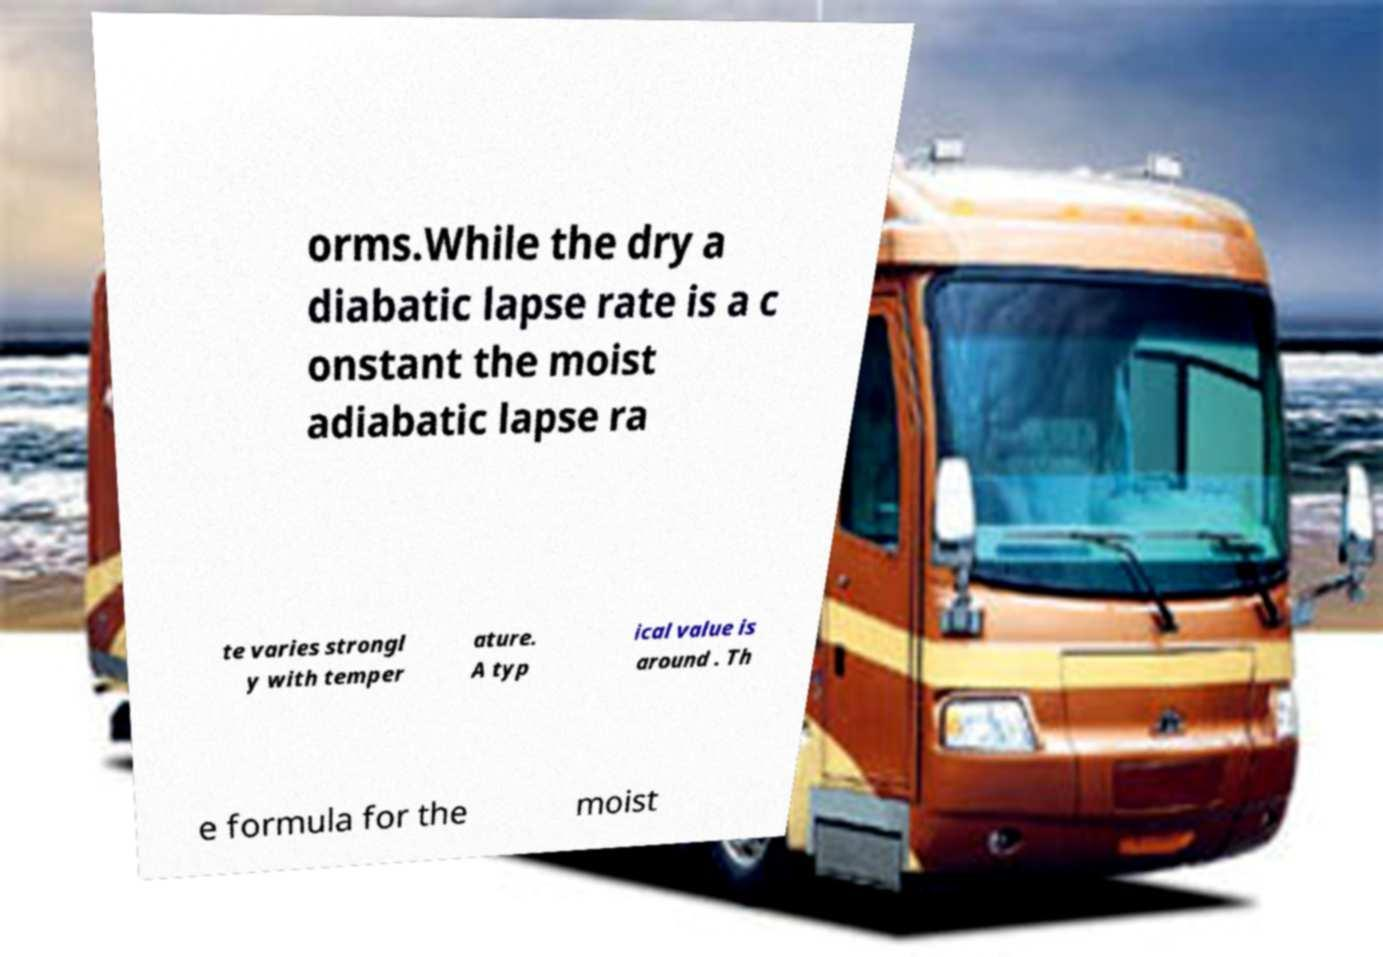I need the written content from this picture converted into text. Can you do that? orms.While the dry a diabatic lapse rate is a c onstant the moist adiabatic lapse ra te varies strongl y with temper ature. A typ ical value is around . Th e formula for the moist 